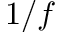<formula> <loc_0><loc_0><loc_500><loc_500>1 / f</formula> 